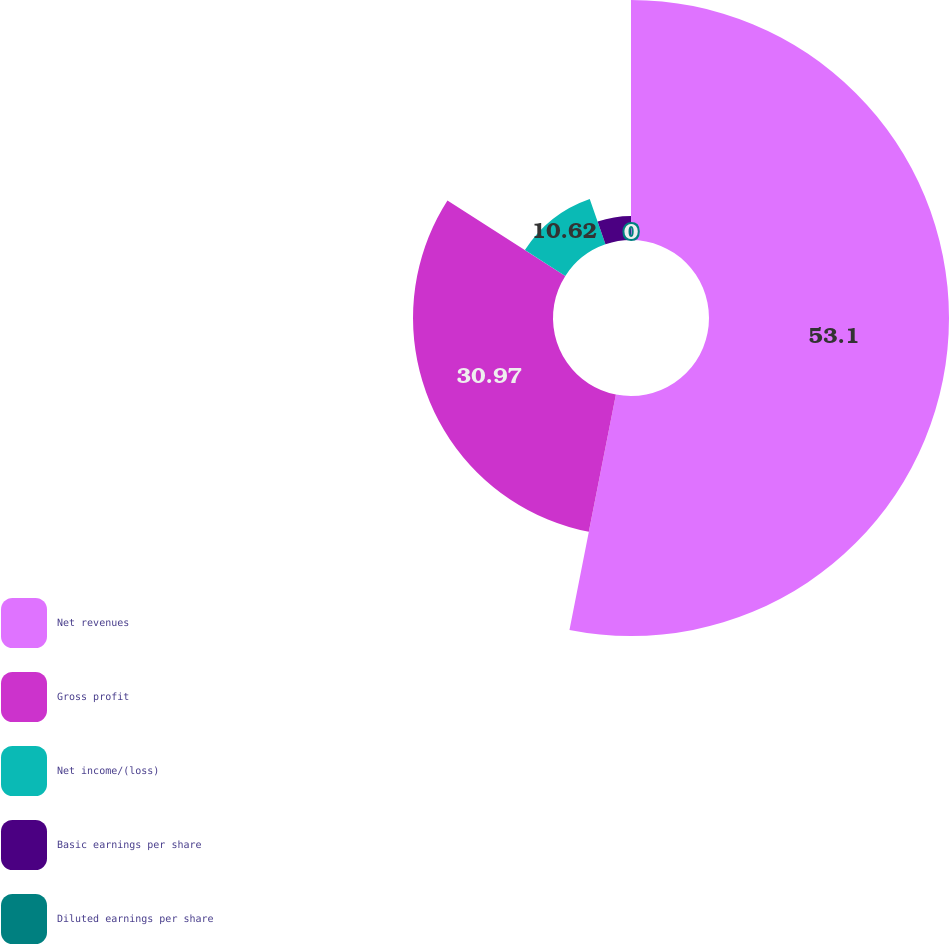<chart> <loc_0><loc_0><loc_500><loc_500><pie_chart><fcel>Net revenues<fcel>Gross profit<fcel>Net income/(loss)<fcel>Basic earnings per share<fcel>Diluted earnings per share<nl><fcel>53.1%<fcel>30.97%<fcel>10.62%<fcel>5.31%<fcel>0.0%<nl></chart> 